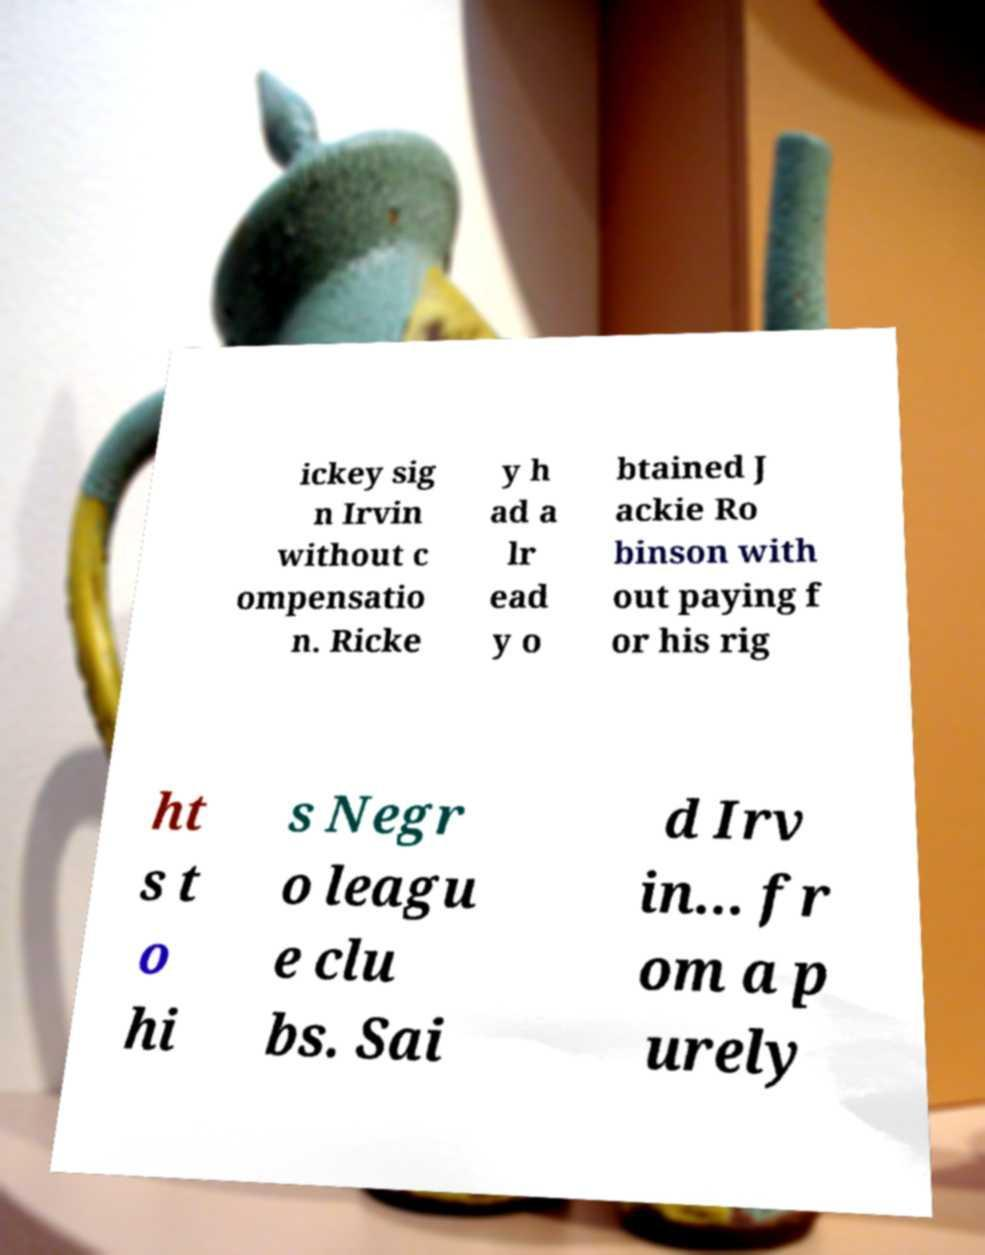Please read and relay the text visible in this image. What does it say? ickey sig n Irvin without c ompensatio n. Ricke y h ad a lr ead y o btained J ackie Ro binson with out paying f or his rig ht s t o hi s Negr o leagu e clu bs. Sai d Irv in... fr om a p urely 